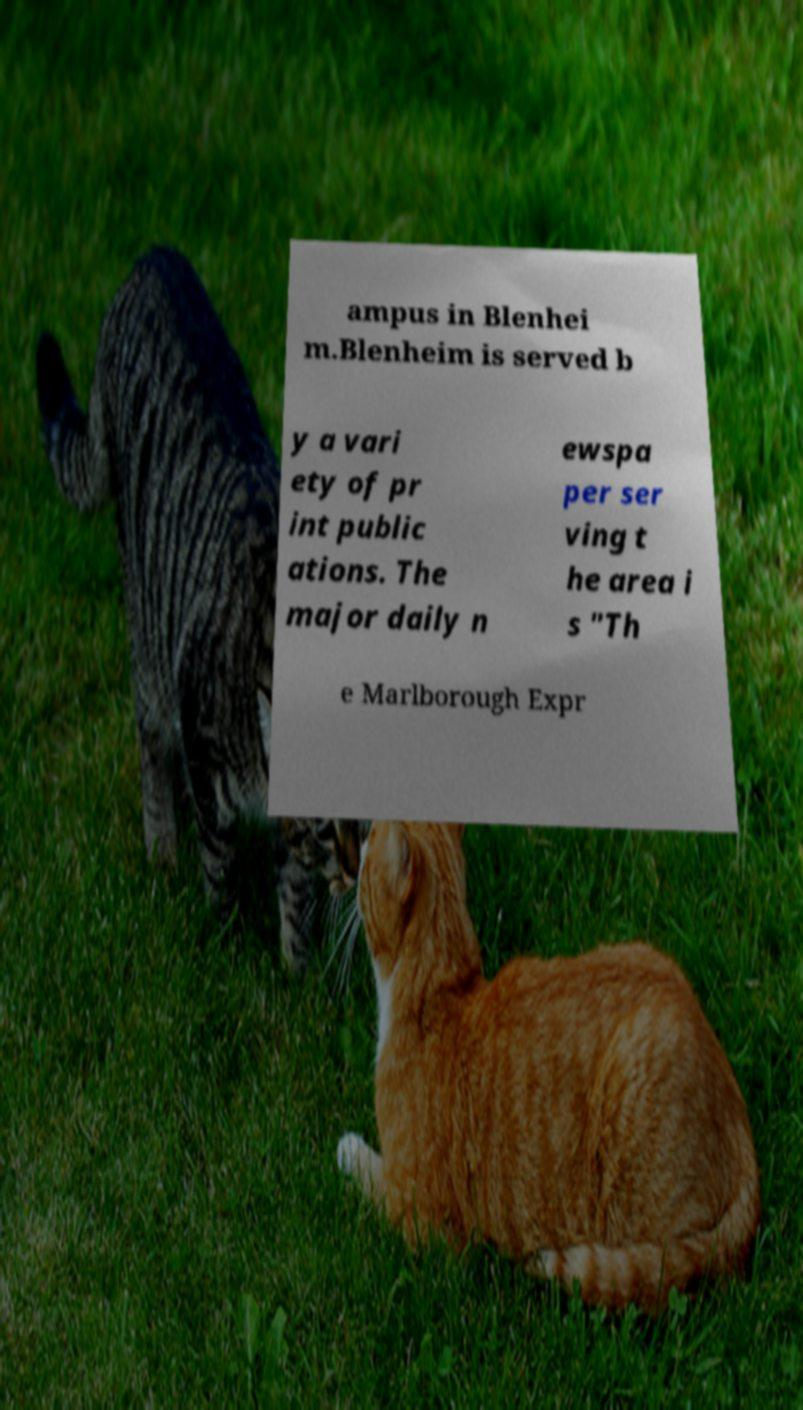Can you accurately transcribe the text from the provided image for me? ampus in Blenhei m.Blenheim is served b y a vari ety of pr int public ations. The major daily n ewspa per ser ving t he area i s "Th e Marlborough Expr 